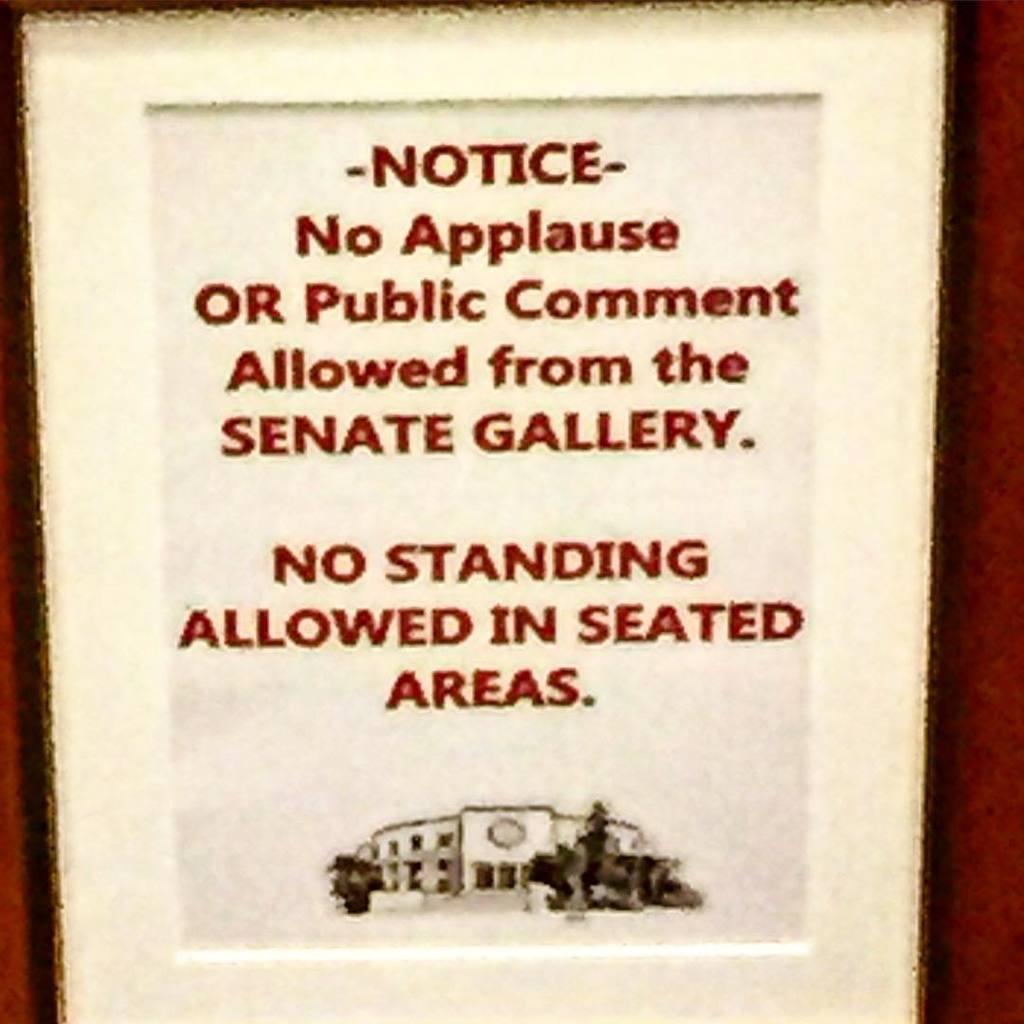What is this for?
Offer a terse response. Unanswerable. What can you not do in seated areas?
Your answer should be very brief. Stand. 